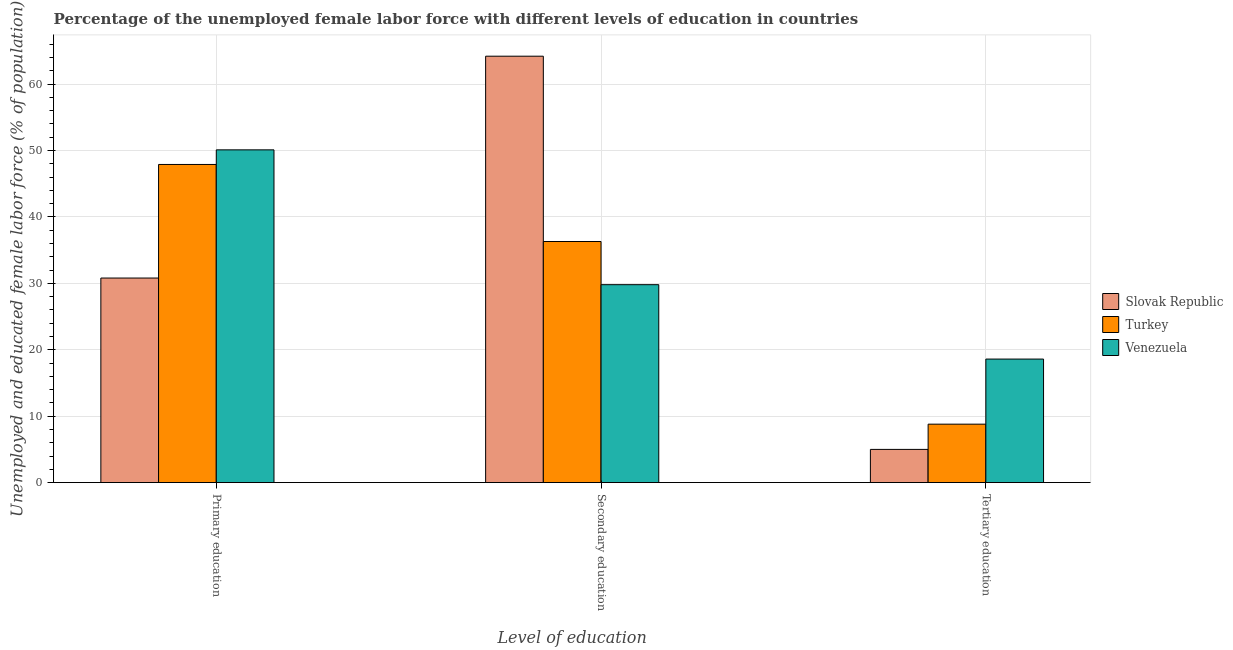How many groups of bars are there?
Give a very brief answer. 3. Are the number of bars per tick equal to the number of legend labels?
Provide a short and direct response. Yes. How many bars are there on the 3rd tick from the left?
Provide a succinct answer. 3. What is the label of the 1st group of bars from the left?
Your answer should be compact. Primary education. What is the percentage of female labor force who received tertiary education in Turkey?
Your answer should be compact. 8.8. Across all countries, what is the maximum percentage of female labor force who received tertiary education?
Ensure brevity in your answer.  18.6. In which country was the percentage of female labor force who received primary education maximum?
Ensure brevity in your answer.  Venezuela. In which country was the percentage of female labor force who received primary education minimum?
Offer a very short reply. Slovak Republic. What is the total percentage of female labor force who received primary education in the graph?
Provide a short and direct response. 128.8. What is the difference between the percentage of female labor force who received secondary education in Venezuela and that in Slovak Republic?
Offer a very short reply. -34.4. What is the difference between the percentage of female labor force who received primary education in Turkey and the percentage of female labor force who received tertiary education in Venezuela?
Offer a very short reply. 29.3. What is the average percentage of female labor force who received secondary education per country?
Keep it short and to the point. 43.43. What is the difference between the percentage of female labor force who received primary education and percentage of female labor force who received secondary education in Turkey?
Keep it short and to the point. 11.6. What is the ratio of the percentage of female labor force who received secondary education in Slovak Republic to that in Turkey?
Keep it short and to the point. 1.77. Is the percentage of female labor force who received primary education in Venezuela less than that in Slovak Republic?
Your answer should be very brief. No. Is the difference between the percentage of female labor force who received tertiary education in Slovak Republic and Venezuela greater than the difference between the percentage of female labor force who received secondary education in Slovak Republic and Venezuela?
Your answer should be very brief. No. What is the difference between the highest and the second highest percentage of female labor force who received primary education?
Make the answer very short. 2.2. What is the difference between the highest and the lowest percentage of female labor force who received primary education?
Offer a terse response. 19.3. In how many countries, is the percentage of female labor force who received tertiary education greater than the average percentage of female labor force who received tertiary education taken over all countries?
Offer a terse response. 1. Is the sum of the percentage of female labor force who received primary education in Venezuela and Slovak Republic greater than the maximum percentage of female labor force who received secondary education across all countries?
Ensure brevity in your answer.  Yes. What does the 3rd bar from the right in Secondary education represents?
Your answer should be very brief. Slovak Republic. How many bars are there?
Provide a succinct answer. 9. Are the values on the major ticks of Y-axis written in scientific E-notation?
Your answer should be very brief. No. Does the graph contain any zero values?
Keep it short and to the point. No. Does the graph contain grids?
Ensure brevity in your answer.  Yes. What is the title of the graph?
Your response must be concise. Percentage of the unemployed female labor force with different levels of education in countries. Does "Iceland" appear as one of the legend labels in the graph?
Provide a succinct answer. No. What is the label or title of the X-axis?
Make the answer very short. Level of education. What is the label or title of the Y-axis?
Your response must be concise. Unemployed and educated female labor force (% of population). What is the Unemployed and educated female labor force (% of population) in Slovak Republic in Primary education?
Provide a short and direct response. 30.8. What is the Unemployed and educated female labor force (% of population) in Turkey in Primary education?
Your answer should be compact. 47.9. What is the Unemployed and educated female labor force (% of population) in Venezuela in Primary education?
Offer a terse response. 50.1. What is the Unemployed and educated female labor force (% of population) of Slovak Republic in Secondary education?
Provide a short and direct response. 64.2. What is the Unemployed and educated female labor force (% of population) in Turkey in Secondary education?
Make the answer very short. 36.3. What is the Unemployed and educated female labor force (% of population) in Venezuela in Secondary education?
Offer a very short reply. 29.8. What is the Unemployed and educated female labor force (% of population) in Slovak Republic in Tertiary education?
Your response must be concise. 5. What is the Unemployed and educated female labor force (% of population) in Turkey in Tertiary education?
Keep it short and to the point. 8.8. What is the Unemployed and educated female labor force (% of population) of Venezuela in Tertiary education?
Your response must be concise. 18.6. Across all Level of education, what is the maximum Unemployed and educated female labor force (% of population) in Slovak Republic?
Make the answer very short. 64.2. Across all Level of education, what is the maximum Unemployed and educated female labor force (% of population) of Turkey?
Give a very brief answer. 47.9. Across all Level of education, what is the maximum Unemployed and educated female labor force (% of population) of Venezuela?
Make the answer very short. 50.1. Across all Level of education, what is the minimum Unemployed and educated female labor force (% of population) in Turkey?
Your response must be concise. 8.8. Across all Level of education, what is the minimum Unemployed and educated female labor force (% of population) of Venezuela?
Provide a short and direct response. 18.6. What is the total Unemployed and educated female labor force (% of population) of Turkey in the graph?
Your answer should be compact. 93. What is the total Unemployed and educated female labor force (% of population) in Venezuela in the graph?
Your answer should be compact. 98.5. What is the difference between the Unemployed and educated female labor force (% of population) of Slovak Republic in Primary education and that in Secondary education?
Give a very brief answer. -33.4. What is the difference between the Unemployed and educated female labor force (% of population) in Venezuela in Primary education and that in Secondary education?
Your response must be concise. 20.3. What is the difference between the Unemployed and educated female labor force (% of population) in Slovak Republic in Primary education and that in Tertiary education?
Give a very brief answer. 25.8. What is the difference between the Unemployed and educated female labor force (% of population) in Turkey in Primary education and that in Tertiary education?
Provide a short and direct response. 39.1. What is the difference between the Unemployed and educated female labor force (% of population) in Venezuela in Primary education and that in Tertiary education?
Provide a short and direct response. 31.5. What is the difference between the Unemployed and educated female labor force (% of population) in Slovak Republic in Secondary education and that in Tertiary education?
Your response must be concise. 59.2. What is the difference between the Unemployed and educated female labor force (% of population) of Slovak Republic in Primary education and the Unemployed and educated female labor force (% of population) of Turkey in Secondary education?
Give a very brief answer. -5.5. What is the difference between the Unemployed and educated female labor force (% of population) of Slovak Republic in Primary education and the Unemployed and educated female labor force (% of population) of Venezuela in Tertiary education?
Your response must be concise. 12.2. What is the difference between the Unemployed and educated female labor force (% of population) in Turkey in Primary education and the Unemployed and educated female labor force (% of population) in Venezuela in Tertiary education?
Your response must be concise. 29.3. What is the difference between the Unemployed and educated female labor force (% of population) in Slovak Republic in Secondary education and the Unemployed and educated female labor force (% of population) in Turkey in Tertiary education?
Provide a succinct answer. 55.4. What is the difference between the Unemployed and educated female labor force (% of population) of Slovak Republic in Secondary education and the Unemployed and educated female labor force (% of population) of Venezuela in Tertiary education?
Provide a short and direct response. 45.6. What is the average Unemployed and educated female labor force (% of population) of Slovak Republic per Level of education?
Your response must be concise. 33.33. What is the average Unemployed and educated female labor force (% of population) of Venezuela per Level of education?
Give a very brief answer. 32.83. What is the difference between the Unemployed and educated female labor force (% of population) in Slovak Republic and Unemployed and educated female labor force (% of population) in Turkey in Primary education?
Make the answer very short. -17.1. What is the difference between the Unemployed and educated female labor force (% of population) of Slovak Republic and Unemployed and educated female labor force (% of population) of Venezuela in Primary education?
Your response must be concise. -19.3. What is the difference between the Unemployed and educated female labor force (% of population) in Turkey and Unemployed and educated female labor force (% of population) in Venezuela in Primary education?
Keep it short and to the point. -2.2. What is the difference between the Unemployed and educated female labor force (% of population) in Slovak Republic and Unemployed and educated female labor force (% of population) in Turkey in Secondary education?
Your answer should be compact. 27.9. What is the difference between the Unemployed and educated female labor force (% of population) in Slovak Republic and Unemployed and educated female labor force (% of population) in Venezuela in Secondary education?
Provide a short and direct response. 34.4. What is the difference between the Unemployed and educated female labor force (% of population) of Turkey and Unemployed and educated female labor force (% of population) of Venezuela in Secondary education?
Give a very brief answer. 6.5. What is the ratio of the Unemployed and educated female labor force (% of population) of Slovak Republic in Primary education to that in Secondary education?
Your answer should be compact. 0.48. What is the ratio of the Unemployed and educated female labor force (% of population) in Turkey in Primary education to that in Secondary education?
Give a very brief answer. 1.32. What is the ratio of the Unemployed and educated female labor force (% of population) in Venezuela in Primary education to that in Secondary education?
Provide a succinct answer. 1.68. What is the ratio of the Unemployed and educated female labor force (% of population) in Slovak Republic in Primary education to that in Tertiary education?
Make the answer very short. 6.16. What is the ratio of the Unemployed and educated female labor force (% of population) of Turkey in Primary education to that in Tertiary education?
Ensure brevity in your answer.  5.44. What is the ratio of the Unemployed and educated female labor force (% of population) in Venezuela in Primary education to that in Tertiary education?
Keep it short and to the point. 2.69. What is the ratio of the Unemployed and educated female labor force (% of population) in Slovak Republic in Secondary education to that in Tertiary education?
Ensure brevity in your answer.  12.84. What is the ratio of the Unemployed and educated female labor force (% of population) of Turkey in Secondary education to that in Tertiary education?
Provide a succinct answer. 4.12. What is the ratio of the Unemployed and educated female labor force (% of population) in Venezuela in Secondary education to that in Tertiary education?
Provide a short and direct response. 1.6. What is the difference between the highest and the second highest Unemployed and educated female labor force (% of population) in Slovak Republic?
Provide a succinct answer. 33.4. What is the difference between the highest and the second highest Unemployed and educated female labor force (% of population) in Turkey?
Your answer should be very brief. 11.6. What is the difference between the highest and the second highest Unemployed and educated female labor force (% of population) of Venezuela?
Your response must be concise. 20.3. What is the difference between the highest and the lowest Unemployed and educated female labor force (% of population) of Slovak Republic?
Keep it short and to the point. 59.2. What is the difference between the highest and the lowest Unemployed and educated female labor force (% of population) in Turkey?
Your answer should be very brief. 39.1. What is the difference between the highest and the lowest Unemployed and educated female labor force (% of population) in Venezuela?
Make the answer very short. 31.5. 